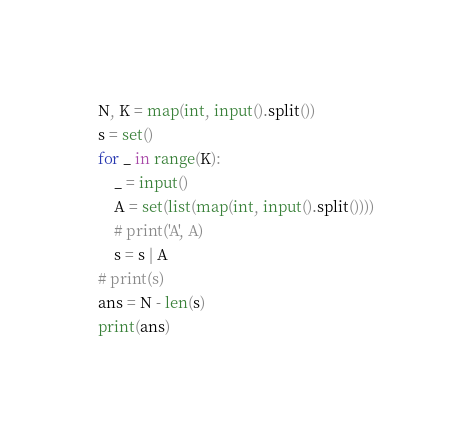<code> <loc_0><loc_0><loc_500><loc_500><_Python_>N, K = map(int, input().split())
s = set()
for _ in range(K):
    _ = input()
    A = set(list(map(int, input().split())))
    # print('A', A)
    s = s | A
# print(s)
ans = N - len(s)
print(ans)
</code> 